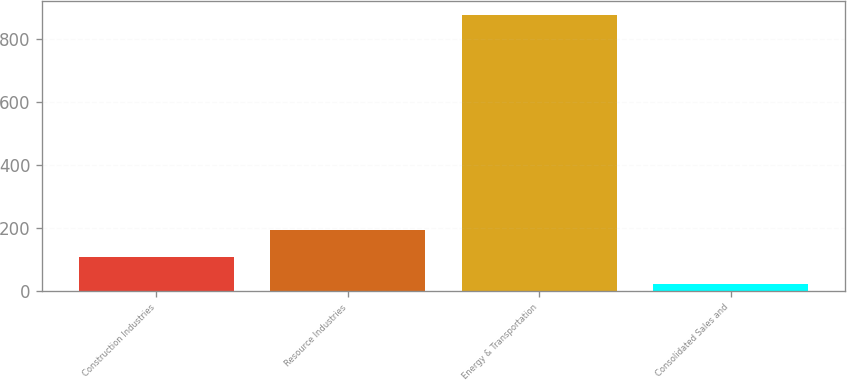Convert chart. <chart><loc_0><loc_0><loc_500><loc_500><bar_chart><fcel>Construction Industries<fcel>Resource Industries<fcel>Energy & Transportation<fcel>Consolidated Sales and<nl><fcel>107.6<fcel>193.2<fcel>878<fcel>22<nl></chart> 